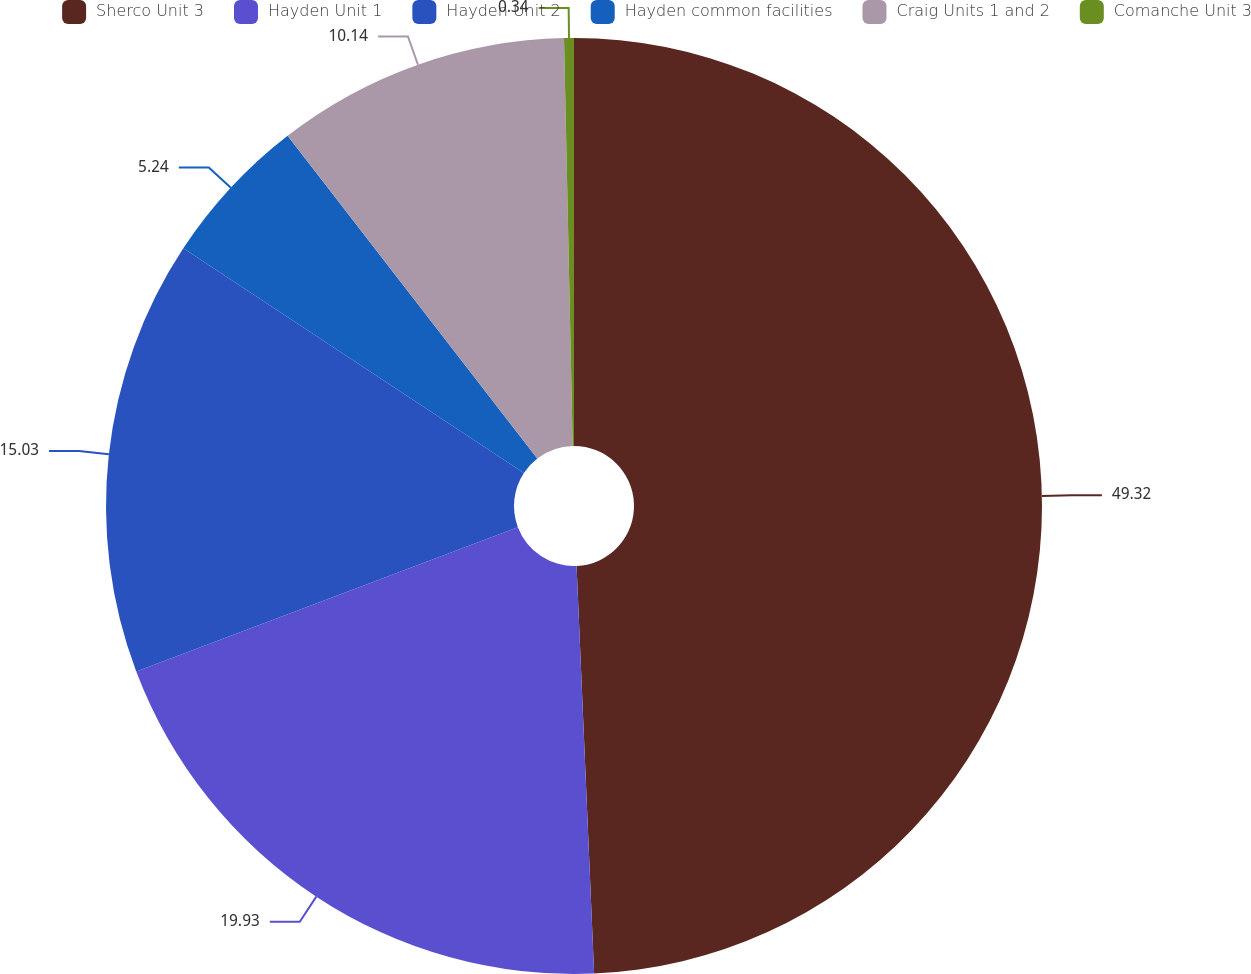Convert chart. <chart><loc_0><loc_0><loc_500><loc_500><pie_chart><fcel>Sherco Unit 3<fcel>Hayden Unit 1<fcel>Hayden Unit 2<fcel>Hayden common facilities<fcel>Craig Units 1 and 2<fcel>Comanche Unit 3<nl><fcel>49.31%<fcel>19.93%<fcel>15.03%<fcel>5.24%<fcel>10.14%<fcel>0.34%<nl></chart> 